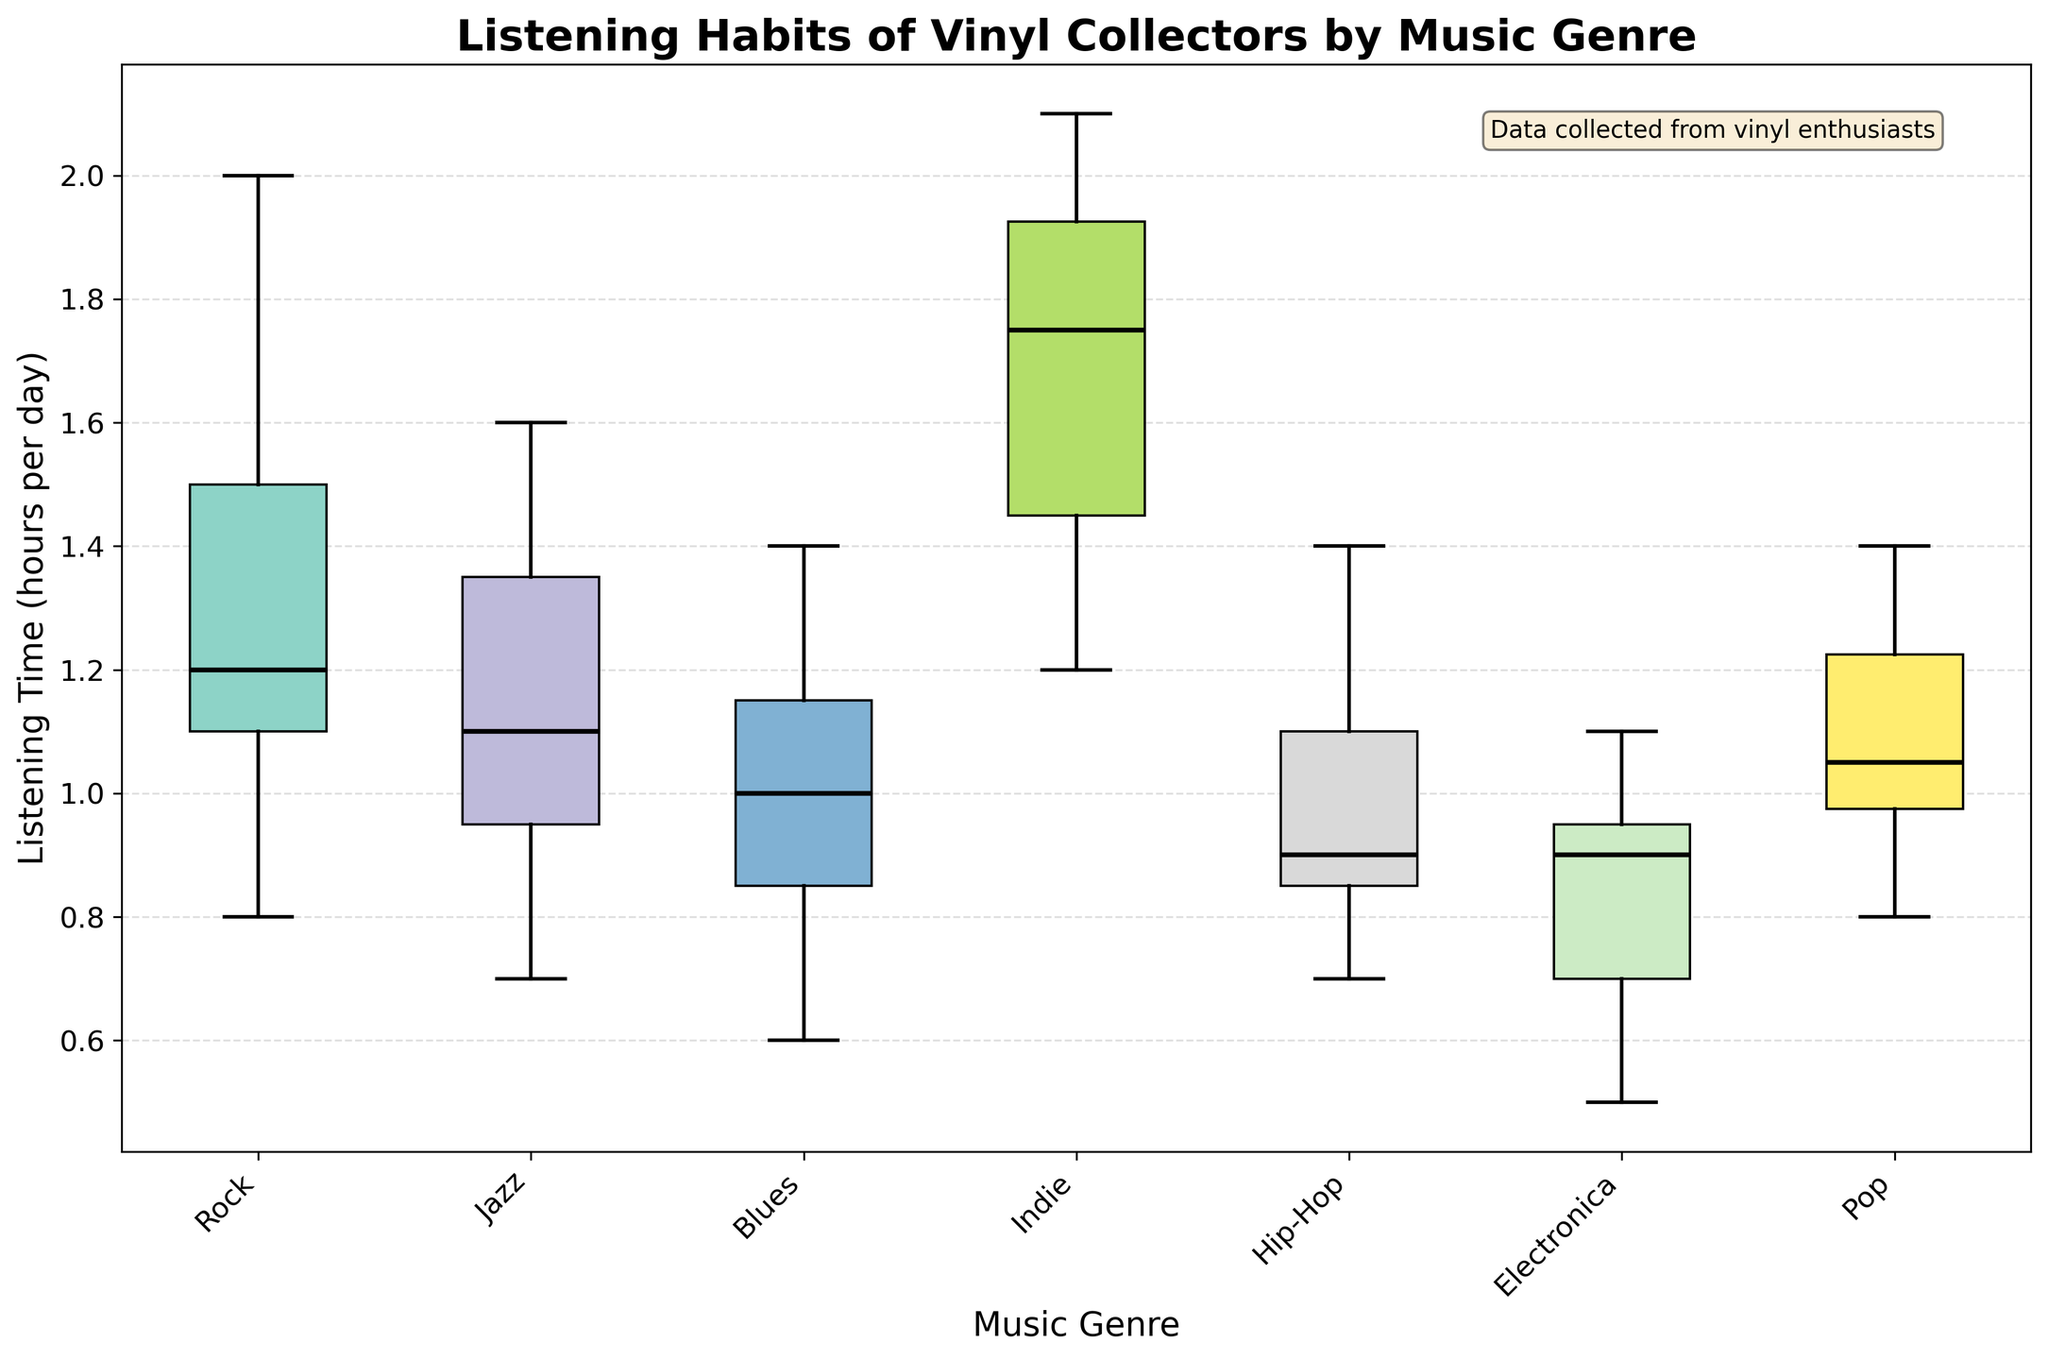What is the title of the figure? The title is usually placed at the top of the figure in a larger, bold font. In this case, the title is "Listening Habits of Vinyl Collectors by Music Genre".
Answer: Listening Habits of Vinyl Collectors by Music Genre What are the names of the music genres shown on the x-axis? The x-axis labels are usually located below the x-axis, and the genres in this case are "Rock", "Jazz", "Blues", "Indie", "Hip-Hop", "Electronica", and "Pop".
Answer: Rock, Jazz, Blues, Indie, Hip-Hop, Electronica, Pop Which genre has the highest median listening time? The median is represented by the black line within each box in the box plot. By visually inspecting these lines, the genre "Indie" has the highest median listening time.
Answer: Indie Which genre has the largest interquartile range (IQR)? The interquartile range (IQR) is the distance between the first quartile (Q1) and the third quartile (Q3). The IQR is represented by the height of the box. Observing the figure, "Indie" appears to have the largest IQR.
Answer: Indie How does the median listening time for Jazz compare to Rock? The median for each genre is the black line within the box. By comparing the medians, Jazz has a slightly higher median than Rock.
Answer: Jazz is higher What is the listening time range for Electronica? The range is from the lower whisker to the upper whisker. For Electronica, this range is approximately from 0.5 to 1.1 hours per day.
Answer: 0.5 to 1.1 hours What is the overall trend in listening times across all genres? The trend can be observed by looking at the positions and sizes of the boxes and whiskers. Listening times generally range from about 0.5 to 2.1 hours per day with notable variability across genres; Indie tends to have higher listening times, while others like Electronica and Blues are lower.
Answer: Most genres fall between 0.5 and 2.1 hours per day, with variation Which genre shows the least variability in listening times? Variability can be assessed by the size of the box and the length of the whiskers. "Hip-Hop" has relatively short whiskers and a small box, indicating less variability in listening times.
Answer: Hip-Hop Are there any genres with outliers? Outliers would be marked by points outside the whiskers, but according to the figure, it doesn't explicitly show outliers. Therefore, no genres show clear outliers.
Answer: No outliers What additional information is provided in the text box on the figure? The text box is usually located in a corner of the figure providing additional context. It mentions that the data is collected from vinyl enthusiasts.
Answer: Data collected from vinyl enthusiasts 